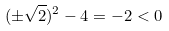Convert formula to latex. <formula><loc_0><loc_0><loc_500><loc_500>( \pm \sqrt { 2 } ) ^ { 2 } - 4 = - 2 < 0</formula> 